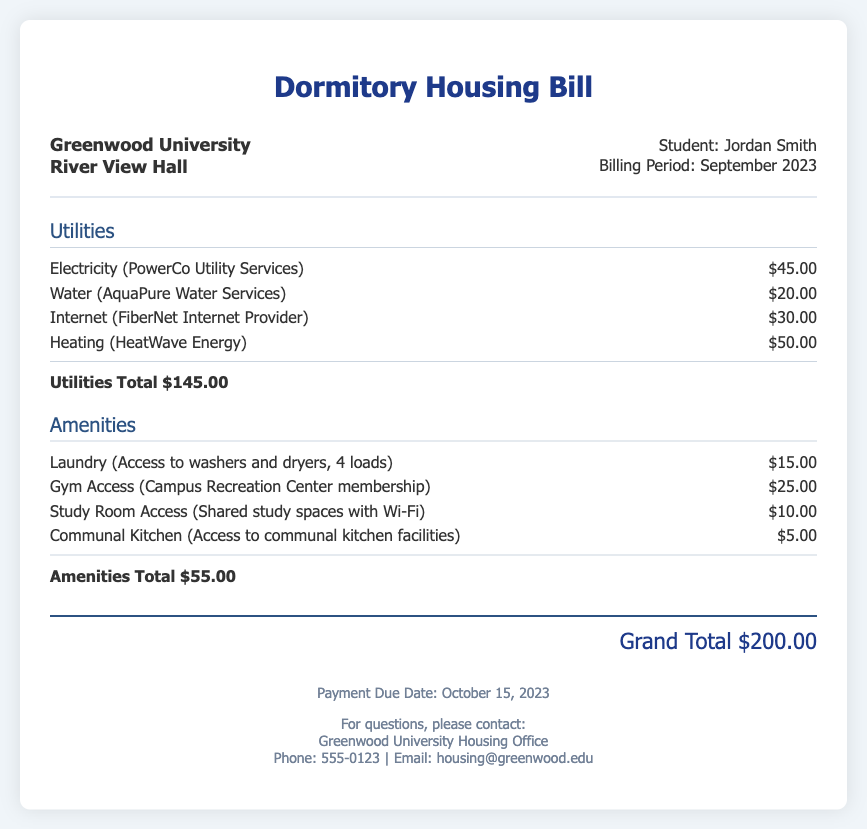What is the total cost for utilities? The total cost for utilities is listed under the utilities section and sums to $145.00.
Answer: $145.00 What is the billing period? The billing period is specified in the student info section and is September 2023.
Answer: September 2023 Who is the student? The student's name is mentioned in the student info section as Jordan Smith.
Answer: Jordan Smith What is the grand total? The grand total is indicated at the bottom of the document and sums to $200.00.
Answer: $200.00 When is the payment due? The payment due date is noted in the footer of the document as October 15, 2023.
Answer: October 15, 2023 What is the cost for gym access? The cost for gym access is included in the amenities section and is listed as $25.00.
Answer: $25.00 Which utility has the highest charge? The utility with the highest charge is heating, which costs $50.00.
Answer: Heating How many loads of laundry are included? The document specifies that access to washers and dryers includes 4 loads of laundry.
Answer: 4 loads What is the name of the university? The name of the university is stated at the top of the document as Greenwood University.
Answer: Greenwood University 